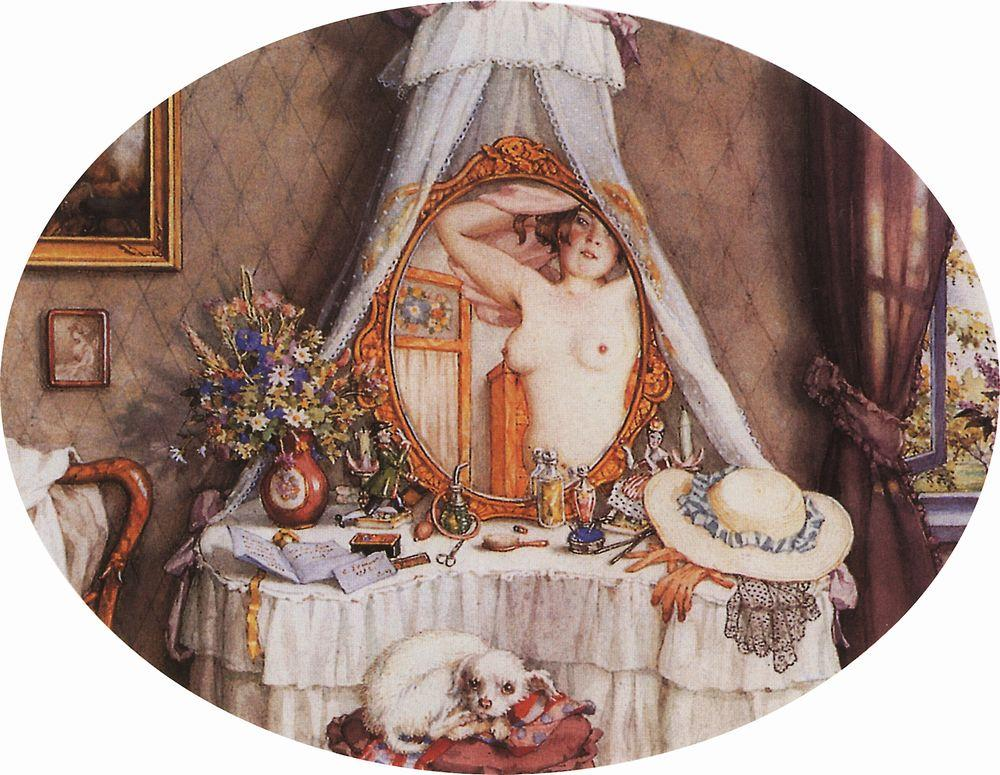If you were to write a short story based on this image, what would it entail? In a quaint, sunlit bedroom adorned with cherished keepsakes, Eliza prepared for her most anticipated day of the year. Each item in her room held a story - the vase of wildflowers picked by her late grandmother, the wide-brimmed hat she wore to her first garden party, and the ornate vanity mirror gifted by a dear friend. Today marked the annual summer soirée, where the townsfolk gathered to celebrate the year's arrival of the season. As she raised her arms to adjust her hair, she caught her reflection smiling back at her, a moment of self-assuredness washing over her. Her loyal dog, Pippin, watched from his red cushion, as if sensing the day's significance. The painting captured this serene moment, where Eliza's anticipation was finely woven with memories and expectations, ready to step into a day of joy, connection, and new memories to be made. How do you think the artist used colors to enhance the visual appeal of the scene? The artist skillfully employs a soft, warm color palette to enhance the visual appeal and evoke a sense of warmth and comfort. The gentle hues of beige, cream, and pastel colors create an inviting and serene atmosphere. The subtle play of light and shadow adds depth and softness to the scene, highlighting the delicate textures of the canopy, the floral arrangements, and the rich fabrics in the room. The vibrant flowers and the red cushion stand out, drawing attention to key elements and providing a pleasing contrast to the more subdued tones. This balance of colors not only enhances the beauty of the scene but also guides the viewer's eye across the painting, creating a harmonious and engaging composition.  Imagine the dog in the image could speak. What thoughts or conversations might it express about the scene? If Pippin the dog could speak, he might express a warm, familial sense of pride and affection towards Eliza. 'Ah, another beautiful morning with Eliza,' he might say, stretching out on his cozy cushion. 'She's getting ready for something special today. I love watching her go through her little routines. She always takes such care with everything. And the flowers on the vanity, they remind me of when her grandmother used to visit us. Such fond memories!' He would likely add, 'I know today will be wonderful, and I get to spend it right by her side.' Pippin's perspective would surely be filled with a sense of loyal companionship and quiet joy, reflecting the intimate bond between them. What might be the backstory of the hat on the table? The hat on the table could be a cherished possession with a sentimental backstory. It might have been Eliza's favorite hat, one she wore during significant events in her life. Perhaps it was a gift from a loved one or a souvenir from a memorable trip. It could also represent her personality – stylish, with a love for elegance and vintage fashion. This hat might have seen many sunny days and happy memories, making it more than just an accessory but a symbol of her experiences and the joyful moments she holds dear.  Describe an alternate reality where this scene takes place on another planet. In an alternate reality, this scene could unfold on a serene, Earth-like planet nestled within a distant galaxy. The bedroom is in a cozy habitat dome designed for comfort and sustainability. Outside the large, curved window, vibrant alien flora bloom in colors unseen on Earth, gently dancing in the light of two nearby suns. The woman stands in front of a vanity mirror with a smooth, sleek design, possibly made of advanced, iridescent materials. Her attire, or lack thereof, signifies a culture that values natural beauty and simplicity. A small, bioluminescent creature, resembling a cross between a dog and a soft plush toy, lies comfortably on a cushion that seems to adjust itself for maximum comfort. The air inside the dome is filled with a faint, pleasant hum generated by the advanced life-support systems. The scene represents the intersection of advanced technology and natural beauty, showing that even on another planet, moments of intimacy and personal reflection remain timeless and universal. 